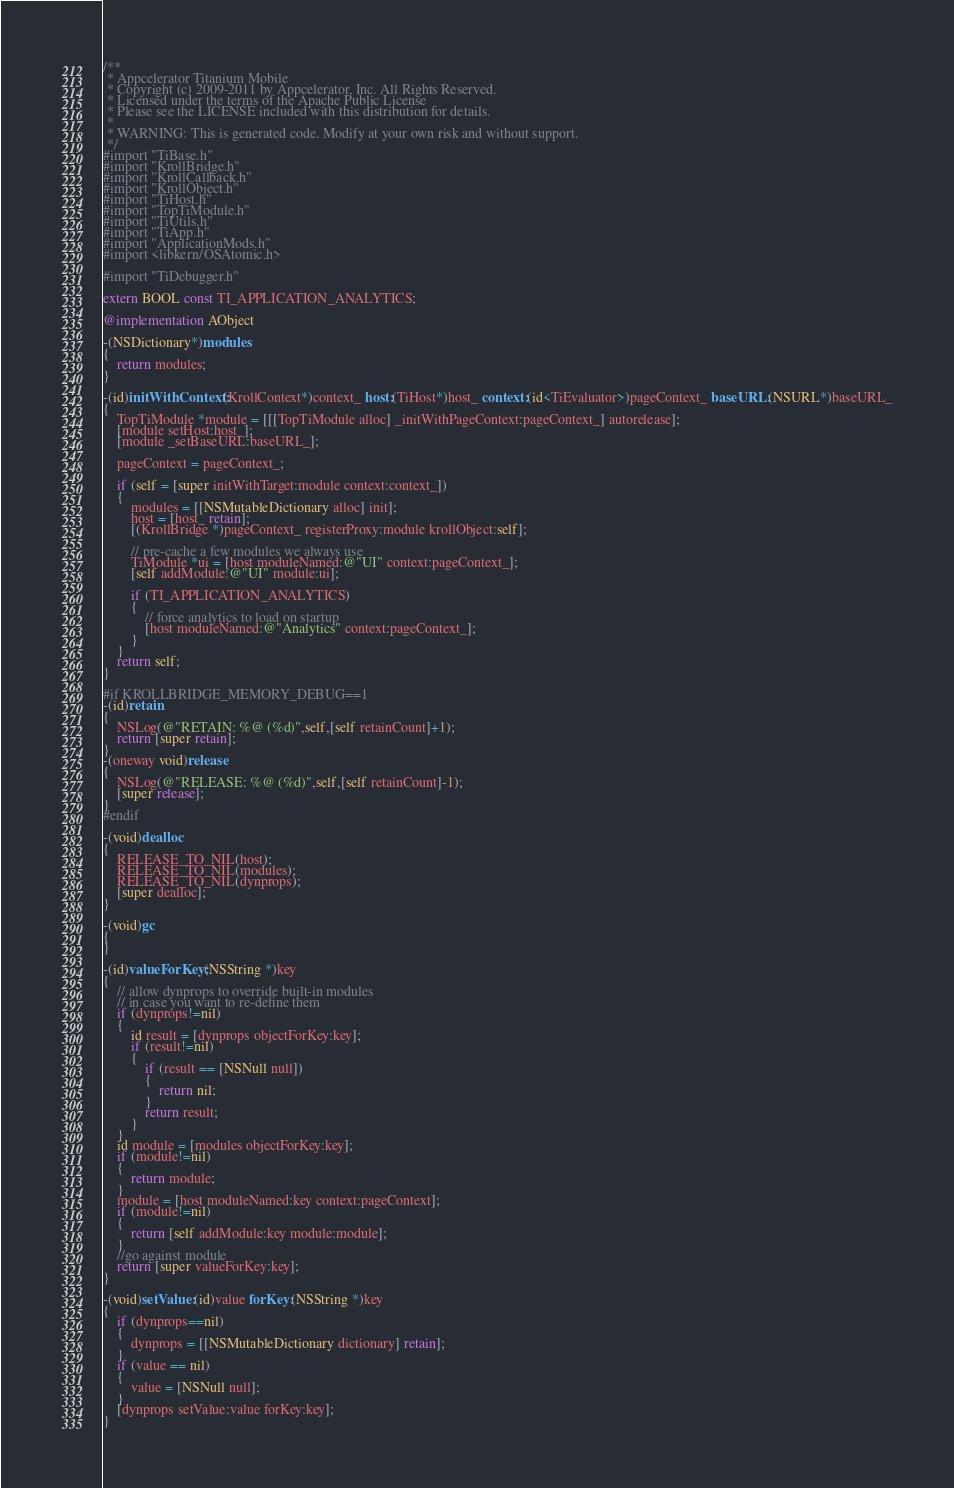<code> <loc_0><loc_0><loc_500><loc_500><_ObjectiveC_>/**
 * Appcelerator Titanium Mobile
 * Copyright (c) 2009-2011 by Appcelerator, Inc. All Rights Reserved.
 * Licensed under the terms of the Apache Public License
 * Please see the LICENSE included with this distribution for details.
 * 
 * WARNING: This is generated code. Modify at your own risk and without support.
 */
#import "TiBase.h"
#import "KrollBridge.h"
#import "KrollCallback.h"
#import "KrollObject.h"
#import "TiHost.h"
#import "TopTiModule.h"
#import "TiUtils.h"
#import "TiApp.h"
#import "ApplicationMods.h"
#import <libkern/OSAtomic.h>

#import "TiDebugger.h"

extern BOOL const TI_APPLICATION_ANALYTICS;

@implementation AObject

-(NSDictionary*)modules
{
	return modules;
}

-(id)initWithContext:(KrollContext*)context_ host:(TiHost*)host_ context:(id<TiEvaluator>)pageContext_ baseURL:(NSURL*)baseURL_
{
	TopTiModule *module = [[[TopTiModule alloc] _initWithPageContext:pageContext_] autorelease];
	[module setHost:host_];
	[module _setBaseURL:baseURL_];
	
	pageContext = pageContext_;
	
	if (self = [super initWithTarget:module context:context_])
	{
		modules = [[NSMutableDictionary alloc] init];
		host = [host_ retain];
		[(KrollBridge *)pageContext_ registerProxy:module krollObject:self];
		
		// pre-cache a few modules we always use
		TiModule *ui = [host moduleNamed:@"UI" context:pageContext_];
		[self addModule:@"UI" module:ui];
		
		if (TI_APPLICATION_ANALYTICS)
		{
			// force analytics to load on startup
			[host moduleNamed:@"Analytics" context:pageContext_];
		}
	}
	return self;
}

#if KROLLBRIDGE_MEMORY_DEBUG==1
-(id)retain
{
	NSLog(@"RETAIN: %@ (%d)",self,[self retainCount]+1);
	return [super retain];
}
-(oneway void)release 
{
	NSLog(@"RELEASE: %@ (%d)",self,[self retainCount]-1);
	[super release];
}
#endif

-(void)dealloc
{
	RELEASE_TO_NIL(host);
	RELEASE_TO_NIL(modules);
	RELEASE_TO_NIL(dynprops);
	[super dealloc];
}

-(void)gc
{
}

-(id)valueForKey:(NSString *)key
{
	// allow dynprops to override built-in modules
	// in case you want to re-define them
	if (dynprops!=nil)
	{
		id result = [dynprops objectForKey:key];
		if (result!=nil)
		{
			if (result == [NSNull null])
			{
				return nil;
			}
			return result;
		}
	}
	id module = [modules objectForKey:key];
	if (module!=nil)
	{
		return module;
	}
	module = [host moduleNamed:key context:pageContext];
	if (module!=nil)
	{
		return [self addModule:key module:module];
	}
	//go against module
	return [super valueForKey:key];
}

-(void)setValue:(id)value forKey:(NSString *)key
{
	if (dynprops==nil)
	{
		dynprops = [[NSMutableDictionary dictionary] retain];
	}
	if (value == nil)
	{
		value = [NSNull null];
	}
	[dynprops setValue:value forKey:key];
}
</code> 